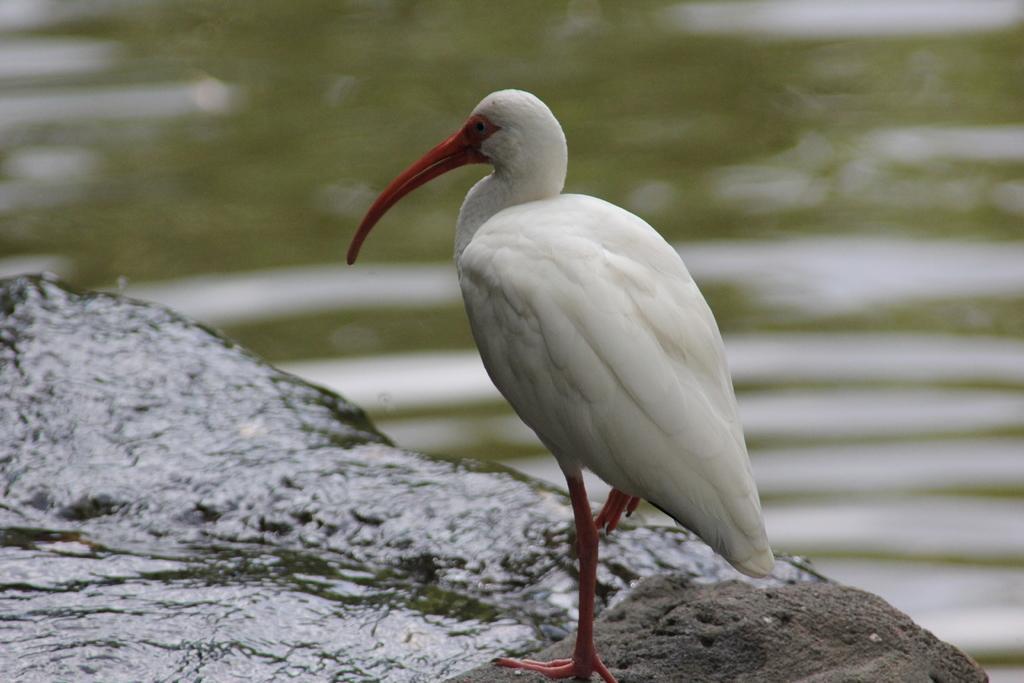Can you describe this image briefly? In this image there is a bird standing in the front and the background is blurry. 